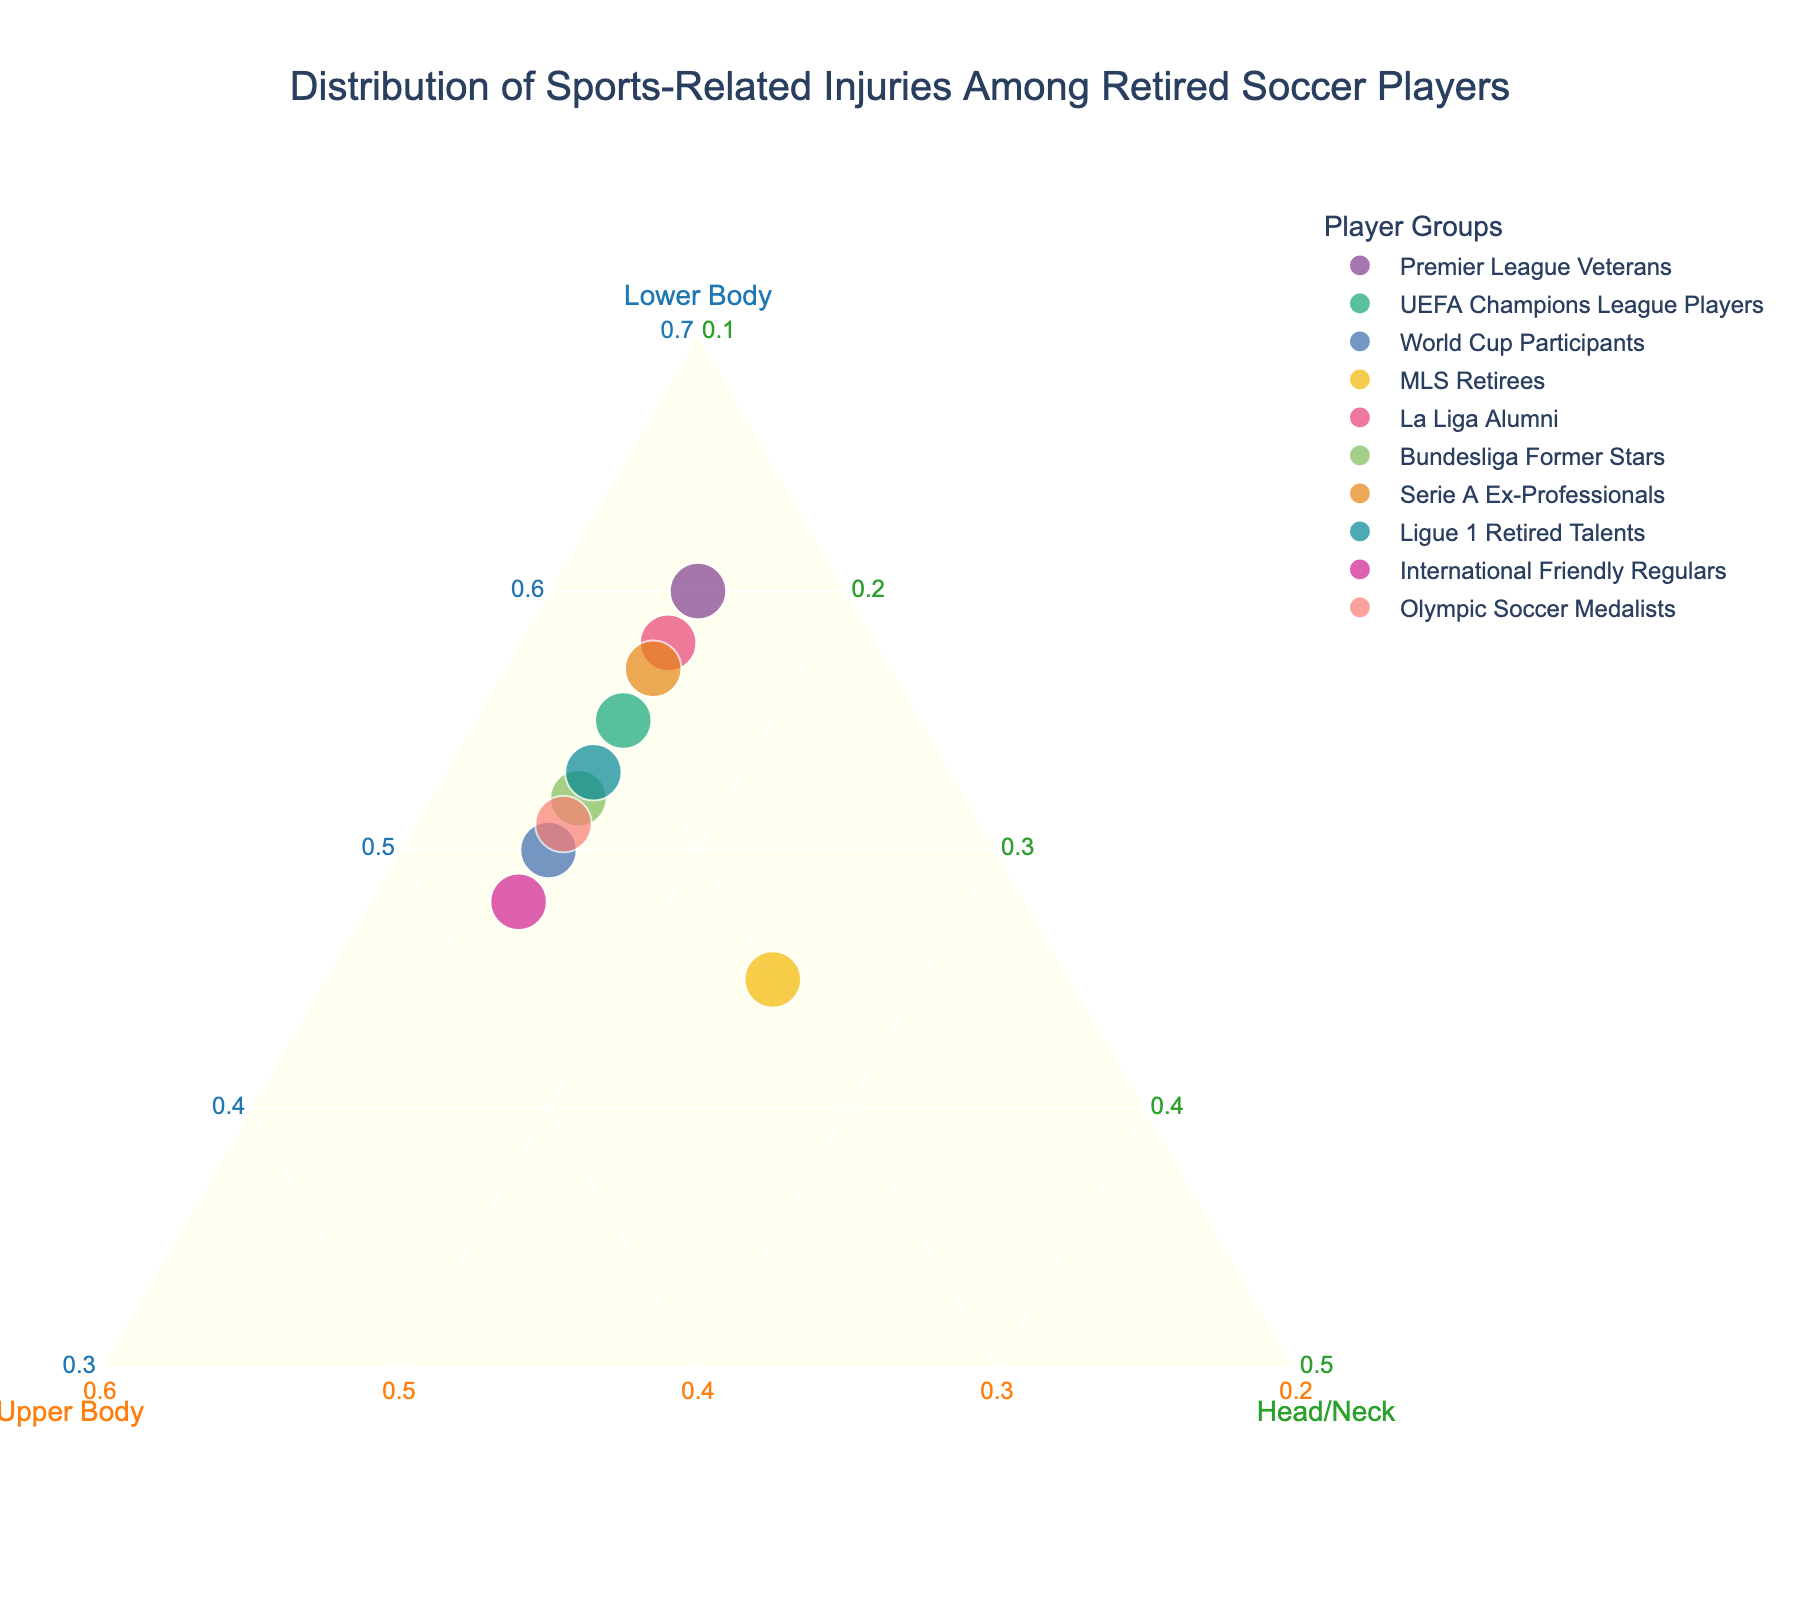How many data points are shown in the plot? By viewing the plot, count the number of points representing different player groups. Each point corresponds to one player group mentioned in the data.
Answer: 10 Which axis represents lower body injuries? In a ternary plot, the axes are typically labeled. Identify the axis labeled "Lower Body" to answer the question.
Answer: a-axis What is the title of the plot? The title is usually displayed at the top of the plot. Read the text to find the title.
Answer: Distribution of Sports-Related Injuries Among Retired Soccer Players Which player group has the highest percentage of lower body injuries? Look at the data points’ positions relative to the lower body (a-axis) to identify which point is placed furthest from the opposite corner. This represents the highest value on this axis.
Answer: Premier League Veterans Which player groups have an equal percentage of head/neck injuries? Check for data points placed along lines that indicate the same proportion of head/neck injuries. All groups with "15" for head/neck injuries will be aligned along one such line in the ternary plot. These are: Premier League Veterans, UEFA Champions League Players, World Cup Participants, La Liga Alumni, Bundesliga Former Stars, Serie A Ex-Professionals, Ligue 1 Retired Talents, and Olympic Soccer Medalists.
Answer: 8 groups Which category is least represented in lower body injuries? Compare the positions of data points relative to the lower body (a-axis). The point closest to the line opposite the lower body corner, indicating the least percentage, corresponds to MLS Retirees.
Answer: MLS Retirees Calculate the average percentage of upper body injuries across all groups. Sum the upper body injury percentages for each group and divide by the number of groups. (25+30+35+30+27+33+28+32+37+34) / 10 = 31.1%
Answer: 31.1% Which player group lies closest to the centroid (33.3%, 33.3%, 33.3%) of the ternary plot? Identify which data point is closest to the ternary plot’s central point, representing equal distribution among the three categories. Look for the player group whose values are most balanced. The data point closest to (50,35,15) is around these equal values (International Friendly Regulars, Olympic Soccer Medalists).
Answer: Olympic Soccer Medalists Compare the distribution of injuries among Bundesliga Former Stars and MLS Retirees. Which category is more pronounced in the MLS Retirees? Examine the relative positions of the data points for these groups concerning each axis. MLS Retirees have the lowest lower body injuries and highest head/neck injuries, whereas Bundesliga has more balanced injuries. Clearly, head/neck injuries are more pronounced in MLS Retirees.
Answer: Head/Neck What is the combined percentage of lower body injuries for La Liga Alumni and Serie A Ex-Professionals? Simply add the lower body injury percentages for these two groups. 58 (La Liga Alumni) + 57 (Serie A Ex-Professionals) = 115%
Answer: 115% 